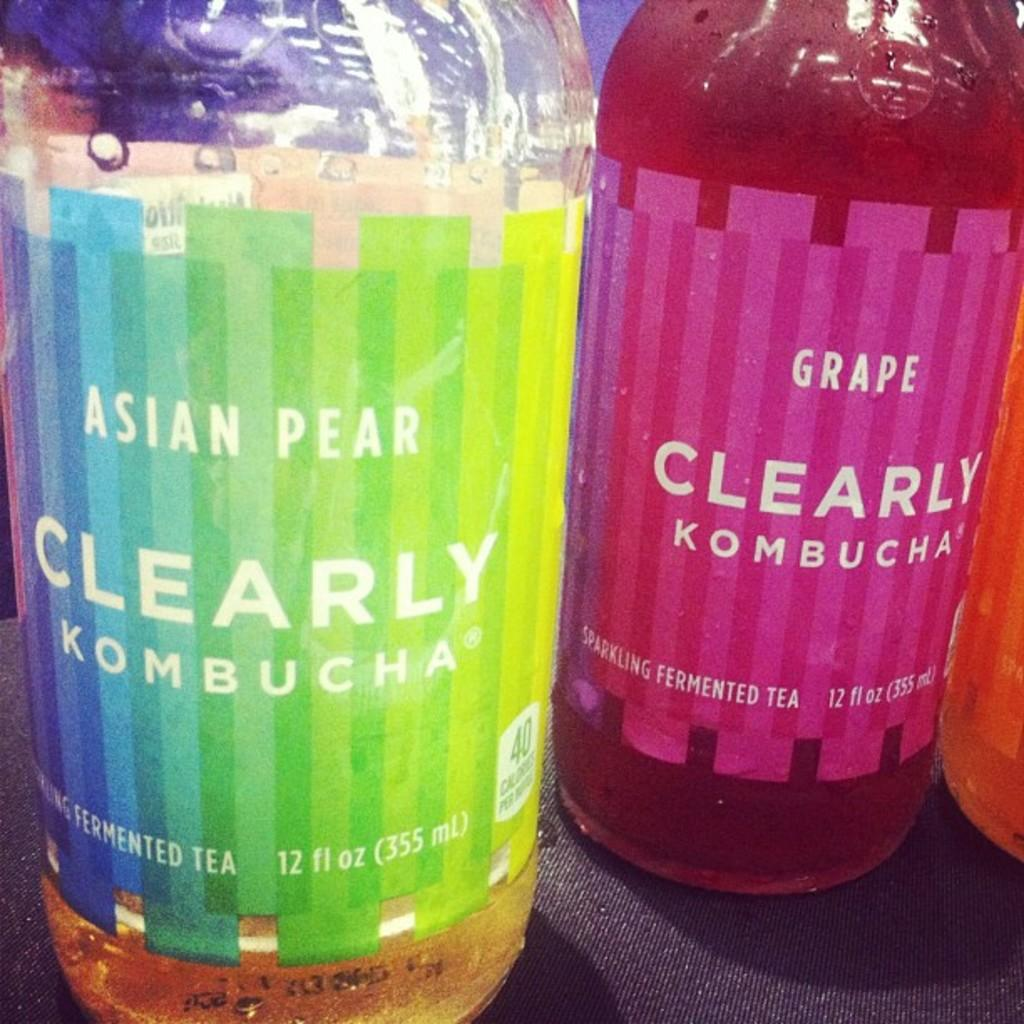<image>
Give a short and clear explanation of the subsequent image. Rainbow colored bottle for Clearly Kombucha next to a red bottle. 